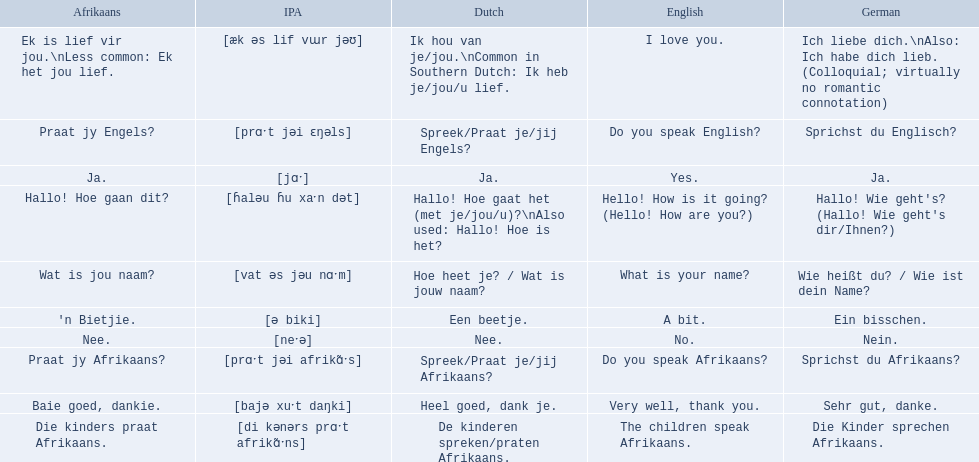In german how do you say do you speak afrikaans? Sprichst du Afrikaans?. How do you say it in afrikaans? Praat jy Afrikaans?. Would you be able to parse every entry in this table? {'header': ['Afrikaans', 'IPA', 'Dutch', 'English', 'German'], 'rows': [['Ek is lief vir jou.\\nLess common: Ek het jou lief.', '[æk əs lif vɯr jəʊ]', 'Ik hou van je/jou.\\nCommon in Southern Dutch: Ik heb je/jou/u lief.', 'I love you.', 'Ich liebe dich.\\nAlso: Ich habe dich lieb. (Colloquial; virtually no romantic connotation)'], ['Praat jy Engels?', '[prɑˑt jəi ɛŋəls]', 'Spreek/Praat je/jij Engels?', 'Do you speak English?', 'Sprichst du Englisch?'], ['Ja.', '[jɑˑ]', 'Ja.', 'Yes.', 'Ja.'], ['Hallo! Hoe gaan dit?', '[ɦaləu ɦu xaˑn dət]', 'Hallo! Hoe gaat het (met je/jou/u)?\\nAlso used: Hallo! Hoe is het?', 'Hello! How is it going? (Hello! How are you?)', "Hallo! Wie geht's? (Hallo! Wie geht's dir/Ihnen?)"], ['Wat is jou naam?', '[vat əs jəu nɑˑm]', 'Hoe heet je? / Wat is jouw naam?', 'What is your name?', 'Wie heißt du? / Wie ist dein Name?'], ["'n Bietjie.", '[ə biki]', 'Een beetje.', 'A bit.', 'Ein bisschen.'], ['Nee.', '[neˑə]', 'Nee.', 'No.', 'Nein.'], ['Praat jy Afrikaans?', '[prɑˑt jəi afrikɑ̃ˑs]', 'Spreek/Praat je/jij Afrikaans?', 'Do you speak Afrikaans?', 'Sprichst du Afrikaans?'], ['Baie goed, dankie.', '[bajə xuˑt daŋki]', 'Heel goed, dank je.', 'Very well, thank you.', 'Sehr gut, danke.'], ['Die kinders praat Afrikaans.', '[di kənərs prɑˑt afrikɑ̃ˑns]', 'De kinderen spreken/praten Afrikaans.', 'The children speak Afrikaans.', 'Die Kinder sprechen Afrikaans.']]} What are the afrikaans phrases? Hallo! Hoe gaan dit?, Baie goed, dankie., Praat jy Afrikaans?, Praat jy Engels?, Ja., Nee., 'n Bietjie., Wat is jou naam?, Die kinders praat Afrikaans., Ek is lief vir jou.\nLess common: Ek het jou lief. For die kinders praat afrikaans, what are the translations? De kinderen spreken/praten Afrikaans., The children speak Afrikaans., Die Kinder sprechen Afrikaans. Which one is the german translation? Die Kinder sprechen Afrikaans. 